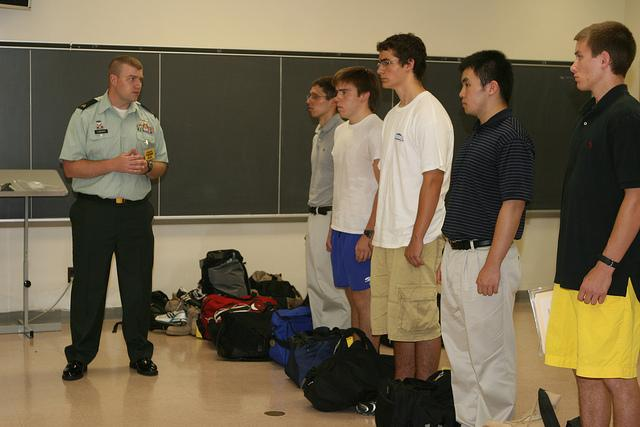What role are persons out of uniform here in?

Choices:
A) captains
B) life guards
C) recruits
D) prisoners recruits 